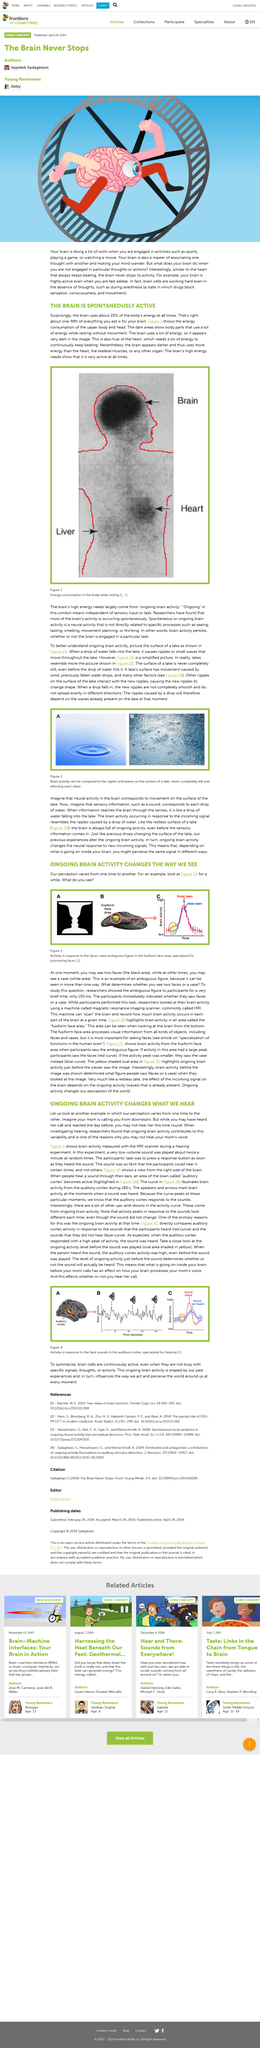Highlight a few significant elements in this photo. The fact that one's brain is active and engaged in various tasks, such as sports, games, or movies, as well as in more passive activities, is a clear indication that the brain is functioning properly. The difference in brain activity between individuals who hear the same sound and those who do not hear it is dependent on the scenario. Researchers are currently investigating the sense of hearing. Anesthesia is a medical procedure that induces a state of unconsciousness, in which patients are insensitive to pain, lack consciousness, and are unable to move. The brain uses more energy than the heart. 